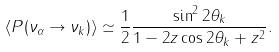Convert formula to latex. <formula><loc_0><loc_0><loc_500><loc_500>\langle P ( \nu _ { \alpha } \rightarrow \nu _ { k } ) \rangle \simeq { \frac { 1 } { 2 } } \frac { \sin ^ { 2 } 2 \theta _ { k } } { 1 - 2 z \cos 2 \theta _ { k } + z ^ { 2 } } .</formula> 